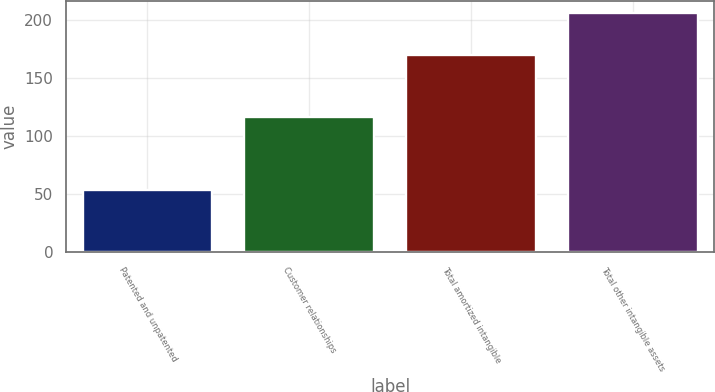Convert chart. <chart><loc_0><loc_0><loc_500><loc_500><bar_chart><fcel>Patented and unpatented<fcel>Customer relationships<fcel>Total amortized intangible<fcel>Total other intangible assets<nl><fcel>53.8<fcel>116.3<fcel>170.1<fcel>206.3<nl></chart> 